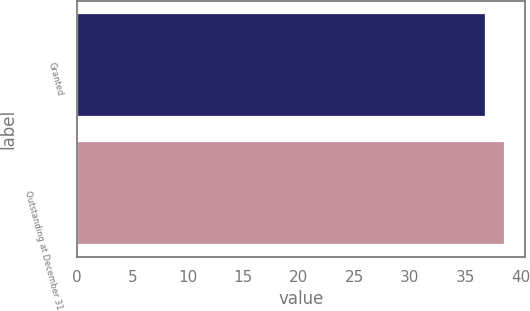Convert chart to OTSL. <chart><loc_0><loc_0><loc_500><loc_500><bar_chart><fcel>Granted<fcel>Outstanding at December 31<nl><fcel>36.75<fcel>38.5<nl></chart> 